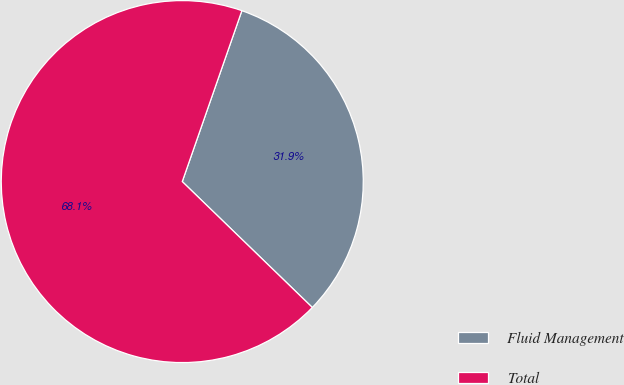Convert chart. <chart><loc_0><loc_0><loc_500><loc_500><pie_chart><fcel>Fluid Management<fcel>Total<nl><fcel>31.9%<fcel>68.1%<nl></chart> 